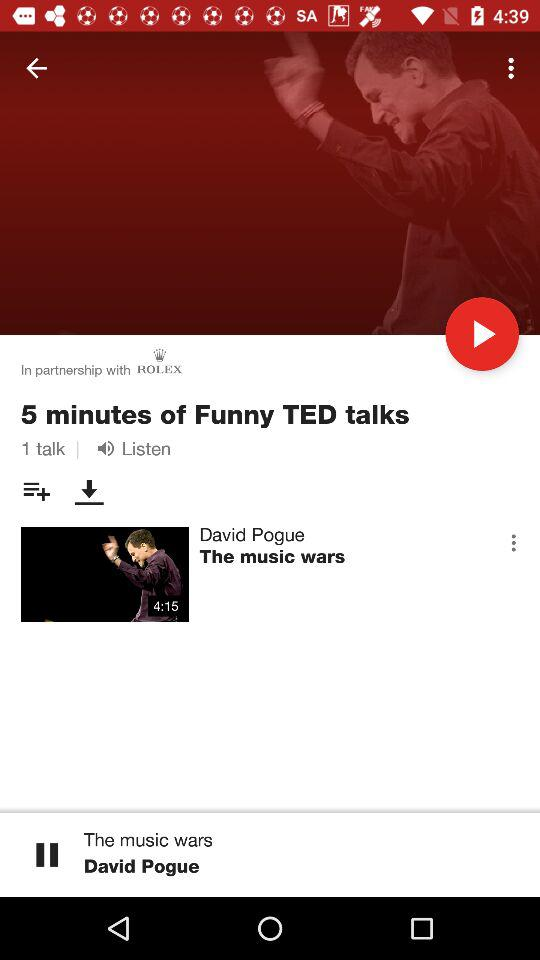How many talks are there?
Answer the question using a single word or phrase. 1 